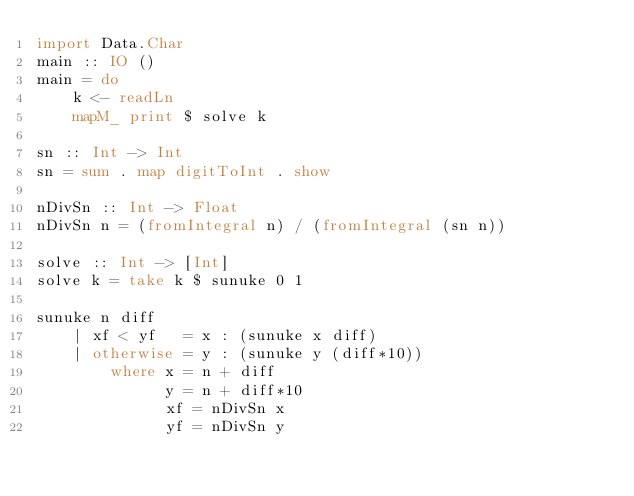Convert code to text. <code><loc_0><loc_0><loc_500><loc_500><_Haskell_>import Data.Char
main :: IO ()
main = do
    k <- readLn
    mapM_ print $ solve k

sn :: Int -> Int
sn = sum . map digitToInt . show

nDivSn :: Int -> Float
nDivSn n = (fromIntegral n) / (fromIntegral (sn n))

solve :: Int -> [Int]
solve k = take k $ sunuke 0 1

sunuke n diff
    | xf < yf   = x : (sunuke x diff)
    | otherwise = y : (sunuke y (diff*10))
        where x = n + diff
              y = n + diff*10
              xf = nDivSn x
              yf = nDivSn y
</code> 